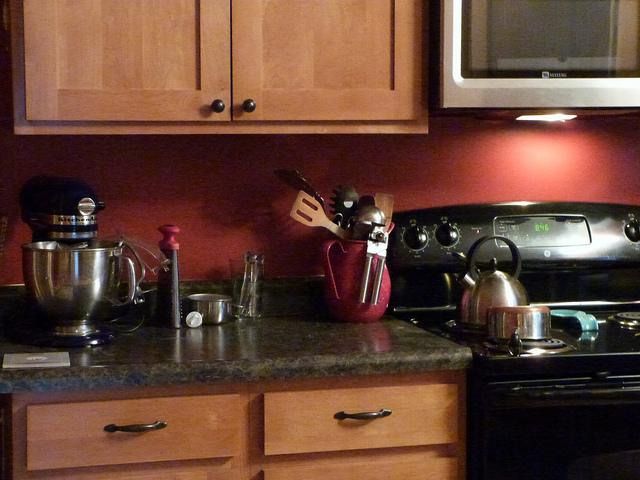What fuels the stove? Please explain your reasoning. electricity. These are electric burners on the stove which means they are powered by electricity. 